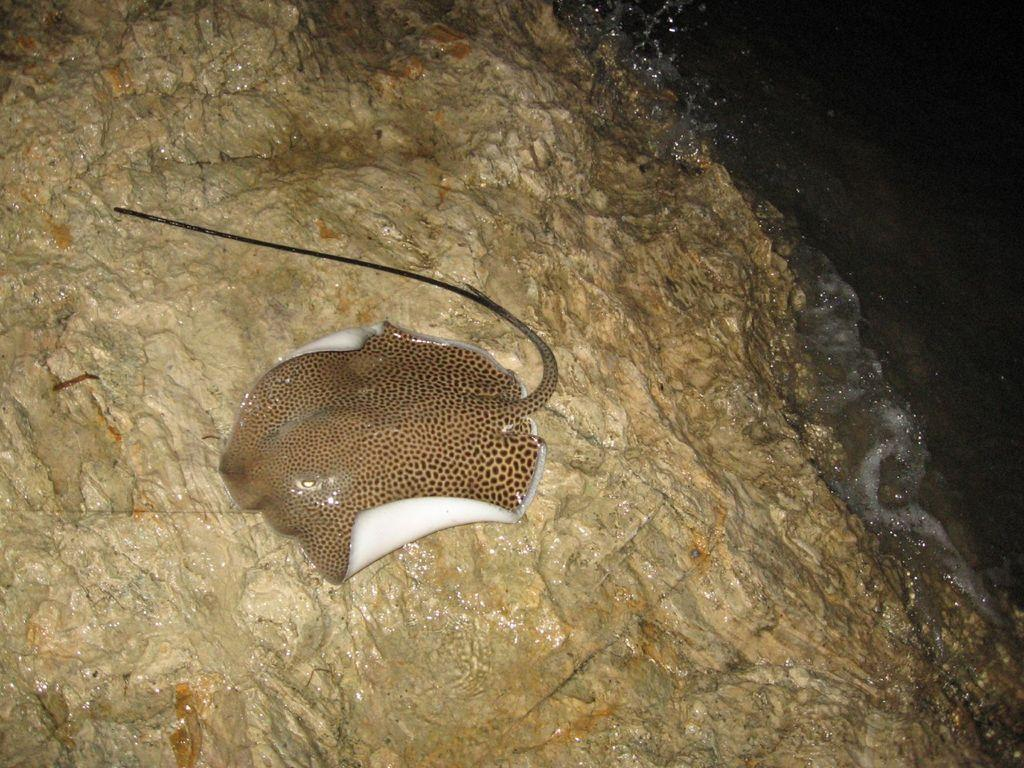What is the main subject of the image? There is a fish on a rock in the image. What type of environment is depicted in the image? There is water visible in the image, suggesting a water-based environment. What type of vest is the beetle wearing in the image? There is no beetle present in the image, and therefore no vest can be observed. 